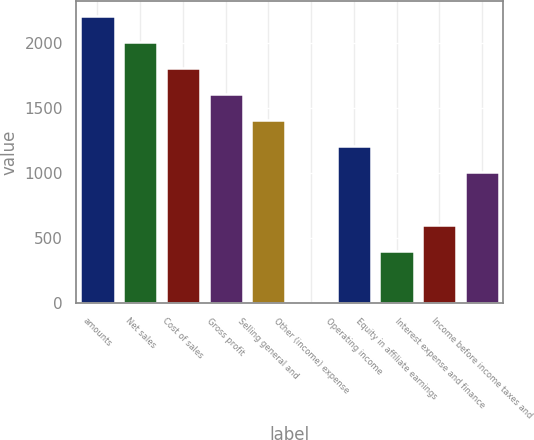<chart> <loc_0><loc_0><loc_500><loc_500><bar_chart><fcel>amounts<fcel>Net sales<fcel>Cost of sales<fcel>Gross profit<fcel>Selling general and<fcel>Other (income) expense<fcel>Operating income<fcel>Equity in affiliate earnings<fcel>Interest expense and finance<fcel>Income before income taxes and<nl><fcel>2207.58<fcel>2007<fcel>1806.42<fcel>1605.84<fcel>1405.26<fcel>1.2<fcel>1204.68<fcel>402.36<fcel>602.94<fcel>1004.1<nl></chart> 